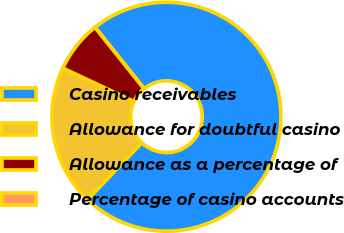Convert chart. <chart><loc_0><loc_0><loc_500><loc_500><pie_chart><fcel>Casino receivables<fcel>Allowance for doubtful casino<fcel>Allowance as a percentage of<fcel>Percentage of casino accounts<nl><fcel>72.85%<fcel>19.86%<fcel>7.29%<fcel>0.0%<nl></chart> 